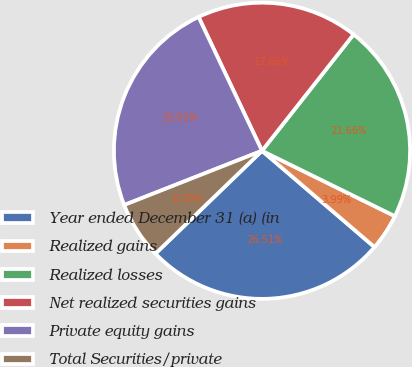Convert chart to OTSL. <chart><loc_0><loc_0><loc_500><loc_500><pie_chart><fcel>Year ended December 31 (a) (in<fcel>Realized gains<fcel>Realized losses<fcel>Net realized securities gains<fcel>Private equity gains<fcel>Total Securities/private<nl><fcel>26.51%<fcel>3.99%<fcel>21.66%<fcel>17.66%<fcel>23.92%<fcel>6.25%<nl></chart> 